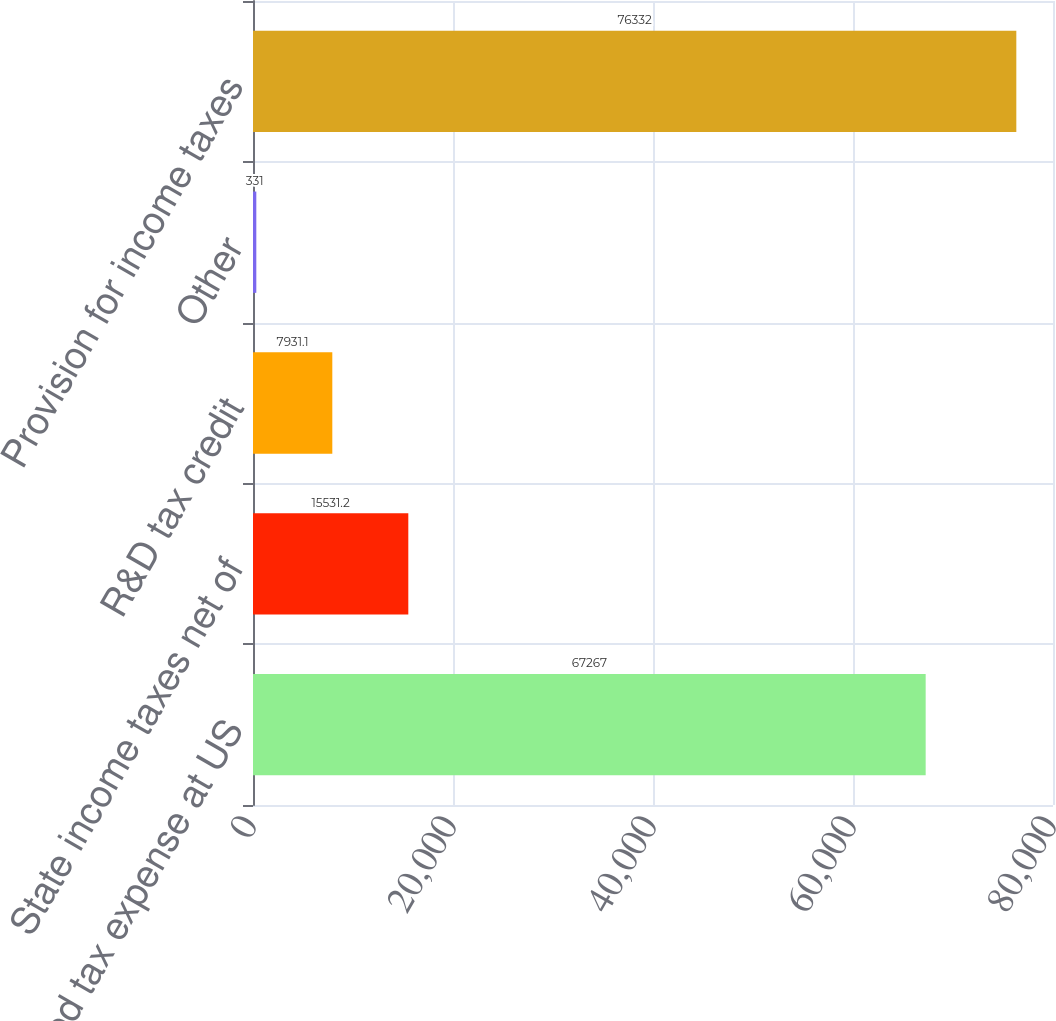Convert chart. <chart><loc_0><loc_0><loc_500><loc_500><bar_chart><fcel>Expected tax expense at US<fcel>State income taxes net of<fcel>R&D tax credit<fcel>Other<fcel>Provision for income taxes<nl><fcel>67267<fcel>15531.2<fcel>7931.1<fcel>331<fcel>76332<nl></chart> 